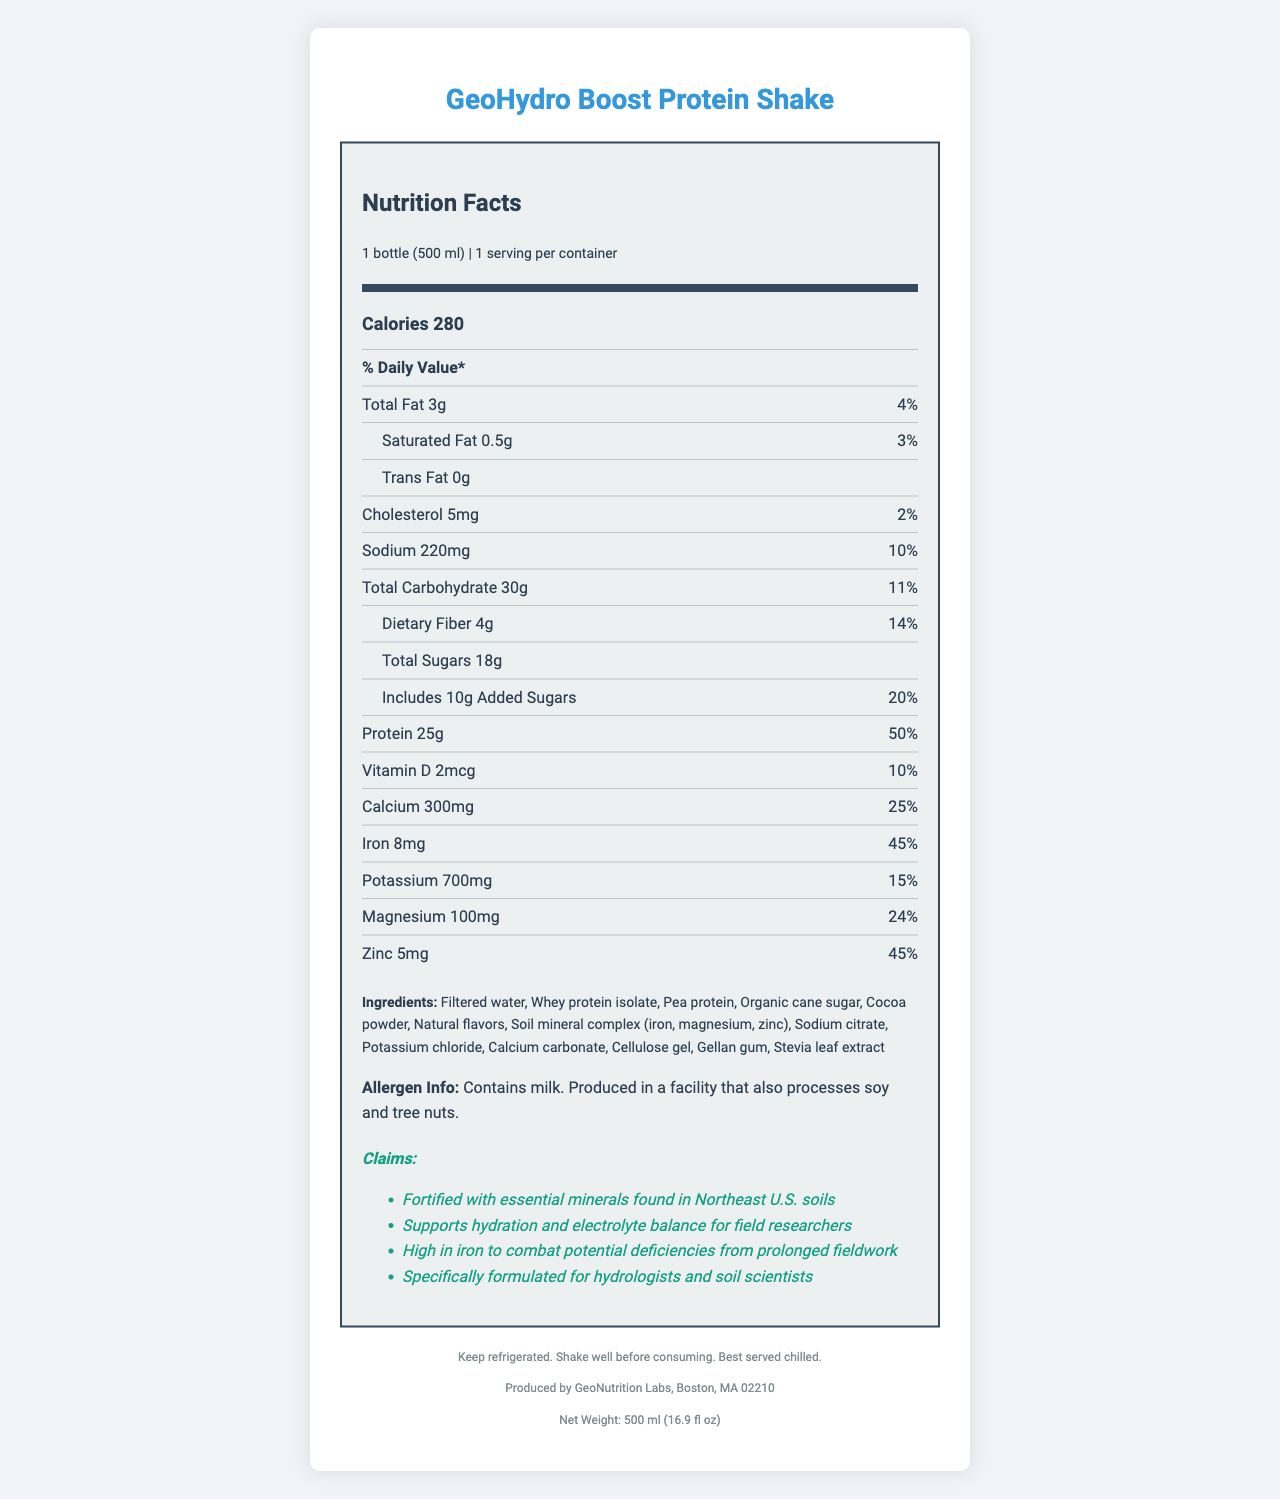what is the serving size of the GeoHydro Boost Protein Shake? The serving size is mentioned at the top of the nutrition label as "1 bottle (500 ml)".
Answer: 1 bottle (500 ml) how much iron is in one serving of the GeoHydro Boost Protein Shake? The iron content is listed in the nutrient information section as 8mg.
Answer: 8mg what is the daily value percentage of protein in the GeoHydro Boost Protein Shake? The daily value percentage for protein is specified as 50% next to the protein amount.
Answer: 50% what are the total calories in one serving? The total calorie content is noted in the main information section as 280 calories.
Answer: 280 calories list three key minerals fortified in the GeoHydro Boost Protein Shake. These minerals are explicitly mentioned in both the ingredients list and the claim statements.
Answer: Iron, magnesium, zinc what percentage of the daily value of vitamin D does the shake provide? A. 5% B. 10% C. 15% D. 20% The percentage of the daily value for vitamin D is given as 10% in the nutrient info section.
Answer: B. 10% which of the following ingredients is not found in the GeoHydro Boost Protein Shake? I. Whey protein isolate II. Vitamin C III. Cocoa powder IV. Pea protein Vitamin C is not listed in the ingredients section of the document.
Answer: II. Vitamin C is the GeoHydro Boost Protein Shake suitable for someone with a nut allergy? The allergen information states that the product is produced in a facility that also processes soy and tree nuts, which may not be safe for someone with a nut allergy.
Answer: No describe the main purpose and features of the GeoHydro Boost Protein Shake. The GeoHydro Boost Protein Shake is described as being formulated specifically for hydrologists and soil scientists. It includes essential minerals for electrolyte balance and hydration, high iron content, and is fortified with soil minerals from the Northeast U.S.
Answer: The GeoHydro Boost Protein Shake is designed for field researchers, particularly hydrologists and soil scientists, to provide nutritional support and hydration. It is fortified with essential minerals such as iron, magnesium, and zinc found in Northeast U.S. soils. The shake supports hydration, electrolyte balance, and high iron content to combat deficiencies from prolonged fieldwork. what is the exact amount of added sugars in the shake? The document states that the shake contains 10g of added sugars in the nutrient information section.
Answer: 10g can the exact source location of the soil minerals be determined from this document? The document does not specify the exact source location of the soil minerals, only that they are from the Northeast U.S.
Answer: Not enough information 